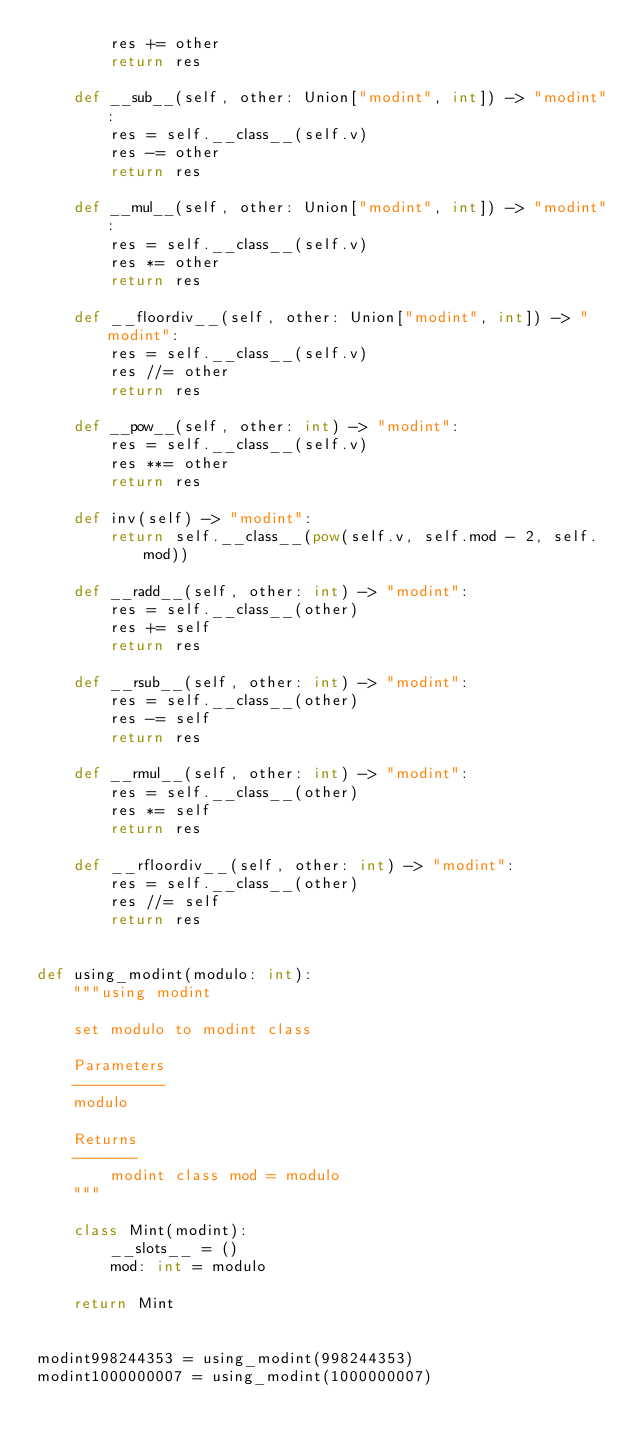Convert code to text. <code><loc_0><loc_0><loc_500><loc_500><_Python_>        res += other
        return res

    def __sub__(self, other: Union["modint", int]) -> "modint":
        res = self.__class__(self.v)
        res -= other
        return res

    def __mul__(self, other: Union["modint", int]) -> "modint":
        res = self.__class__(self.v)
        res *= other
        return res

    def __floordiv__(self, other: Union["modint", int]) -> "modint":
        res = self.__class__(self.v)
        res //= other
        return res

    def __pow__(self, other: int) -> "modint":
        res = self.__class__(self.v)
        res **= other
        return res

    def inv(self) -> "modint":
        return self.__class__(pow(self.v, self.mod - 2, self.mod))

    def __radd__(self, other: int) -> "modint":
        res = self.__class__(other)
        res += self
        return res

    def __rsub__(self, other: int) -> "modint":
        res = self.__class__(other)
        res -= self
        return res

    def __rmul__(self, other: int) -> "modint":
        res = self.__class__(other)
        res *= self
        return res

    def __rfloordiv__(self, other: int) -> "modint":
        res = self.__class__(other)
        res //= self
        return res


def using_modint(modulo: int):
    """using modint

    set modulo to modint class

    Parameters
    ----------
    modulo

    Returns
    -------
        modint class mod = modulo
    """

    class Mint(modint):
        __slots__ = ()
        mod: int = modulo

    return Mint


modint998244353 = using_modint(998244353)
modint1000000007 = using_modint(1000000007)
</code> 